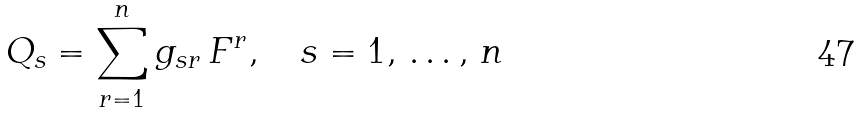<formula> <loc_0><loc_0><loc_500><loc_500>Q _ { s } = \sum _ { r = 1 } ^ { n } g _ { s r } \, F ^ { r } , \quad s = 1 , \, \dots , \, n</formula> 